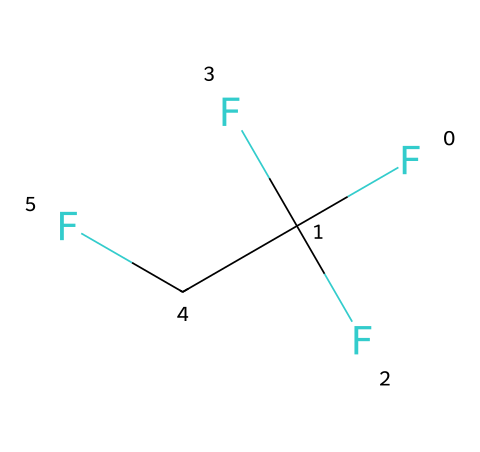What is the name of this refrigerant? The chemical is a hydrofluorocarbon commonly known as R-134a. This is identified through its structure, which consists of carbon (C), fluorine (F), and hydrogen (H) atoms arranged in a specific way characteristic of R-134a.
Answer: R-134a How many carbon atoms are present in R-134a? The SMILES representation indicates there are two carbon atoms in the chain (C) as seen in the structure, one of which is central and branched. Counting them gives a total of 2 carbon atoms.
Answer: 2 What is the total number of fluorine atoms in the molecule? In the provided SMILES, the presence of three F atoms is indicated by the three occurrences of 'F' attached to the carbon framework. Counting these gives a total of 3 fluorine atoms.
Answer: 3 What type of bonds are present in R-134a? The structure shows that R-134a contains single bonds between carbon and hydrogen, and carbon and fluorine. Recognizing the connectivity from the structure indicates that all connections are single bonds.
Answer: single bonds Why is R-134a considered a hydrofluorocarbon? R-134a contains both hydrogen and fluorine atoms as part of its structure. Specifically, the presence of hydrogen (H) atoms along with fluorinated carbons (C) confirms it as a hydrofluorocarbon type.
Answer: hydrofluorocarbon What property of R-134a allows it to function as a refrigerant? The structure of R-134a suggests low boiling point characteristics due to its molecular configuration and molecular weight, leading to its capability to vaporize easily, which is essential for its function as a refrigerant.
Answer: low boiling point How many hydrogen atoms are found in R-134a? The SMILES representation indicates there are two hydrogen atoms attached to the carbon structure, which can be counted by analyzing how many hydrogen atoms bond with the carbon framework in the structure.
Answer: 2 